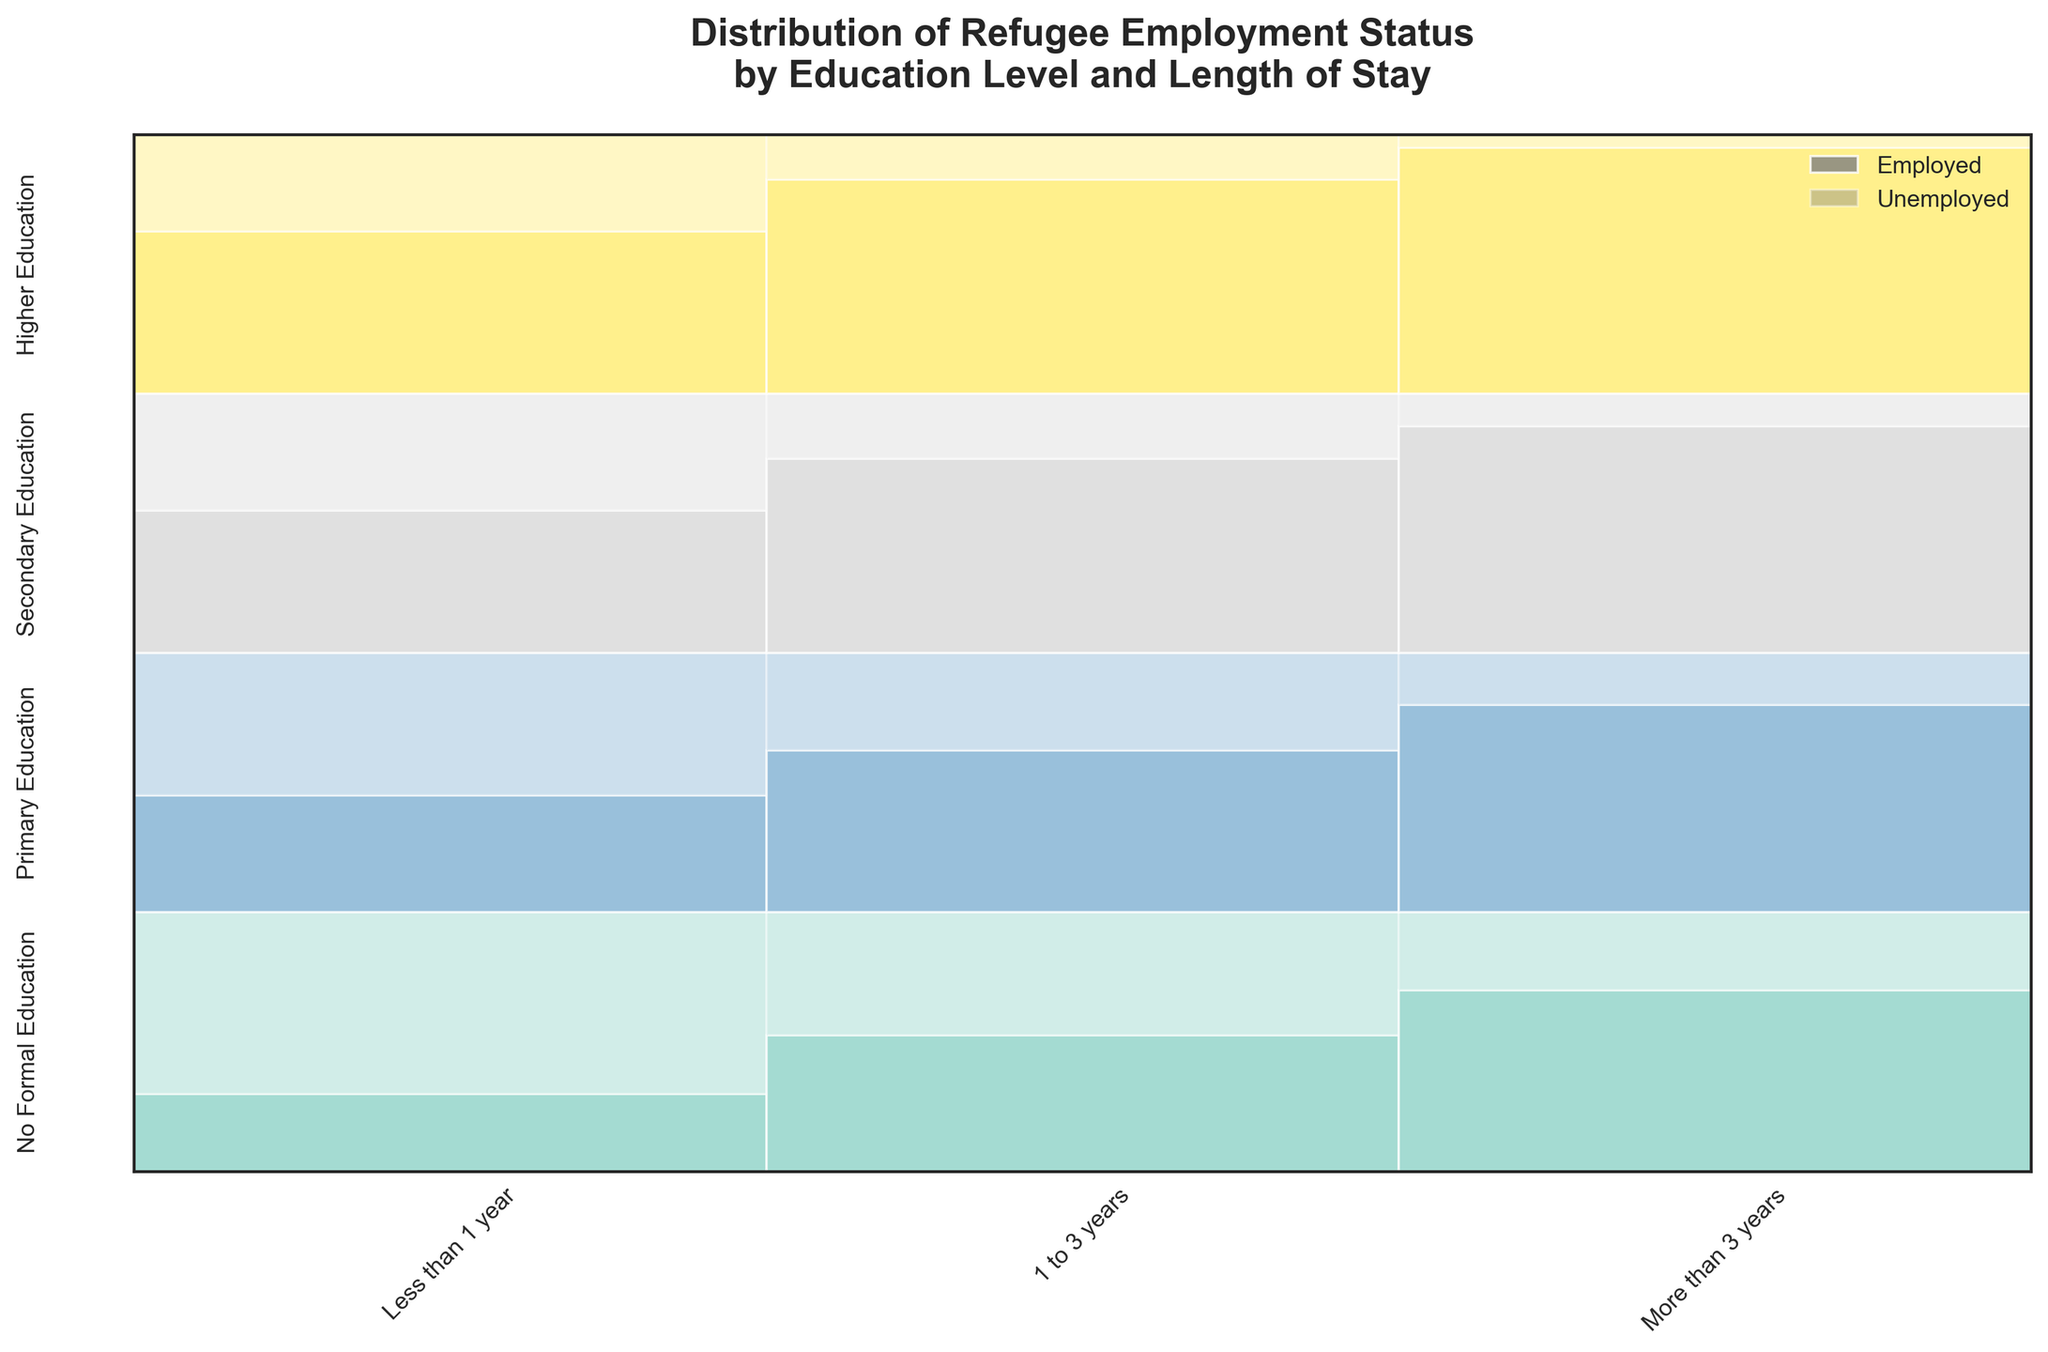What is the title of the figure? The title of the figure is typically located at the top and is a summary of what the figure represents. By looking at the top of the plot, we can see the title clearly.
Answer: Distribution of Refugee Employment Status by Education Level and Length of Stay Which education level has the highest total count of refugees employed for more than 3 years? To determine this, we need to look at the category "More than 3 years" for each education level and compare the heights of the employed sections. Higher Education has the tallest rectangle in this category.
Answer: Higher Education How does the employment status of refugees with no formal education change with the length of stay? We need to look at how the heights of the "Employed" and "Unemployed" sections change across the "Less than 1 year", "1 to 3 years", and "More than 3 years" for "No Formal Education". The employment rate increases while the unemployment rate decreases with longer stays.
Answer: Employment increases, Unemployment decreases Among those with secondary education, which length of stay has the highest employment rate? We need to check the division of the "Employed" section height over the total for "Less than 1 year", "1 to 3 years", and "More than 3 years" categories within "Secondary Education". "More than 3 years" shows the highest rate.
Answer: More than 3 years How does the proportion of employed refugees with higher education change with the length of stay? Observe the changes in the height of the "Employed" section for "Less than 1 year", "1 to 3 years", and "More than 3 years" in "Higher Education". The proportion of employed refugees increases with a longer length of stay.
Answer: Increases with longer stay Compare the employment rates of refugees with primary education for those staying less than 1 year and more than 3 years. Which is higher? Compare the height of the "Employed" sections for the lengths of stay "Less than 1 year" and "More than 3 years" in "Primary Education". The height for "More than 3 years" is higher.
Answer: More than 3 years What can be inferred about the relationship between education level and employment status for refugees? Analyzing the figure, we observe that higher education levels have higher employment rates, and longer stays generally increase employment rates. This relationship suggests that both education and the length of stay are positively correlated with employment status.
Answer: Higher education and longer stays lead to higher employment rates Overall, which length of stay category tends to have the highest employment rates for refugees across all education levels? We need to compare the heights of the "Employed" sections in all education levels for "Less than 1 year", "1 to 3 years", and "More than 3 years". The category "More than 3 years" shows consistently higher employment rates.
Answer: More than 3 years For refugees with higher education, what percent of those staying 1 to 3 years are employed? To find the percentage, divide the count of employed refugees by the total count for "Higher Education" staying "1 to 3 years". (330 Employed / (330 Employed + 70 Unemployed)) * 100 = 82.5%
Answer: 82.5% 